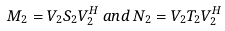<formula> <loc_0><loc_0><loc_500><loc_500>M _ { 2 } = V _ { 2 } S _ { 2 } V _ { 2 } ^ { H } \, a n d \, N _ { 2 } = V _ { 2 } T _ { 2 } V _ { 2 } ^ { H }</formula> 